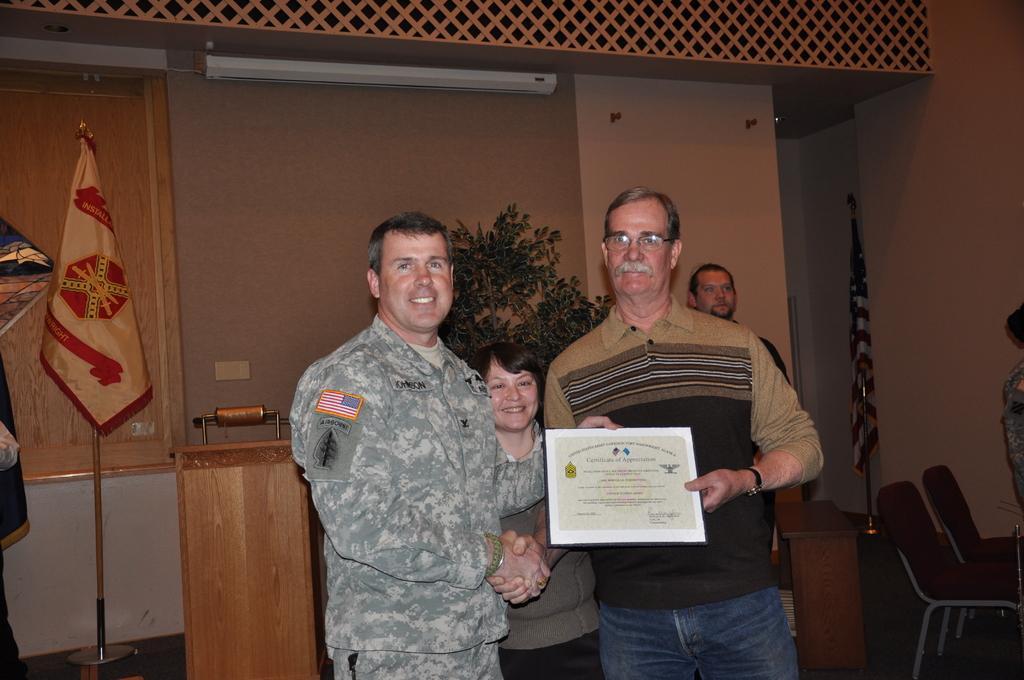Can you describe this image briefly? This image is taken indoors. In the background there is a wall. There is a plant, there is a podium and a flag on the floor. In the middle of the image two men and a woman are standing on the floor and a man is holding a certificate in his hand. On the right side of the image there are two empty chairs and there is a flag and a man is standing on the floor. 